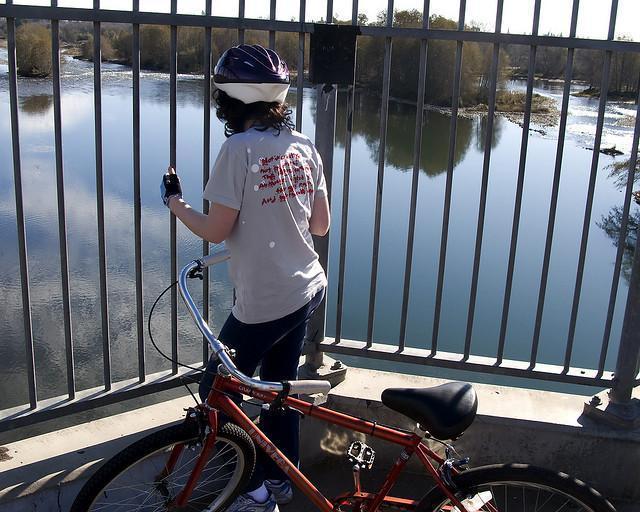How many cars in this picture are white?
Give a very brief answer. 0. 